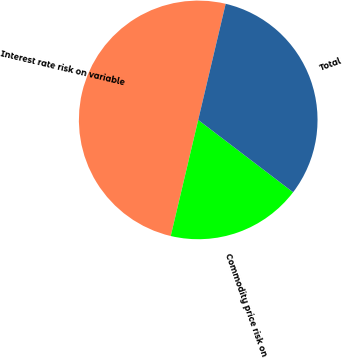<chart> <loc_0><loc_0><loc_500><loc_500><pie_chart><fcel>Interest rate risk on variable<fcel>Commodity price risk on<fcel>Total<nl><fcel>50.0%<fcel>18.33%<fcel>31.67%<nl></chart> 